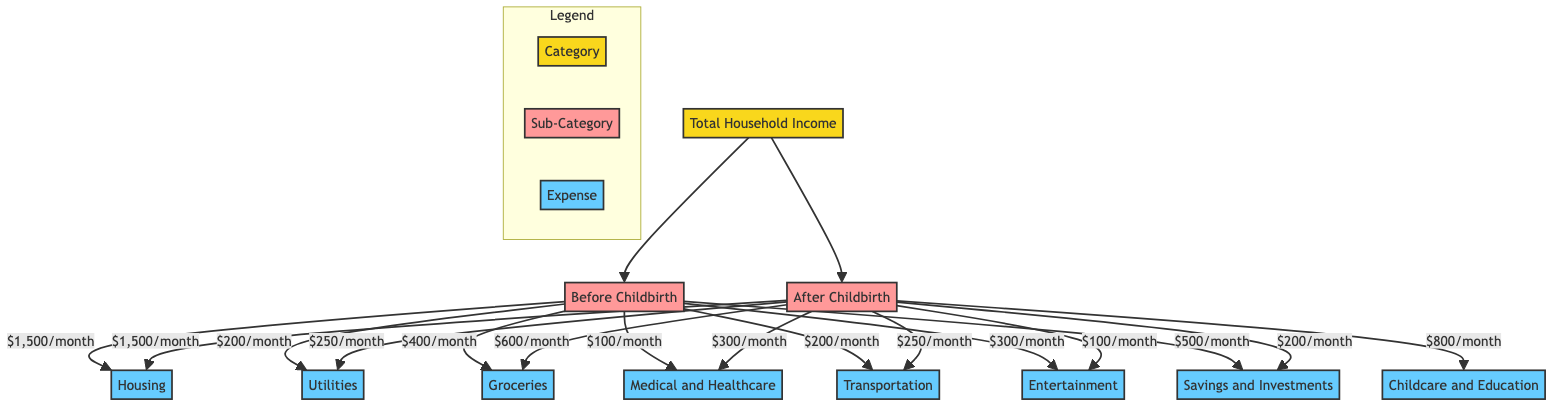What is the monthly expense for housing before childbirth? The diagram indicates that the monthly expense for housing before childbirth is $1,500. This is directly located under the "Before Childbirth" category connected to the "Housing" node.
Answer: $1,500 What is the increase in the monthly grocery expense after childbirth? The diagram shows that the monthly grocery expense before childbirth is $400, while after childbirth, it rises to $600. The increase can be calculated as $600 - $400, which equals $200.
Answer: $200 How much is allocated monthly for childcare and education after childbirth? According to the diagram, the monthly allocation for childcare and education after childbirth is $800. This is explicitly stated under the "After Childbirth" category connected to the "Childcare and Education" node.
Answer: $800 What is the total monthly spending on medical and healthcare before childbirth? The monthly expense for medical and healthcare before childbirth is $100, as shown in the diagram, under the "Before Childbirth" category connected to the "Medical and Healthcare" node.
Answer: $100 What is the ratio of savings after childbirth to savings before childbirth? The diagram indicates that savings before childbirth is $500 and after childbirth is $200. The ratio can be calculated as $200 : $500, which simplifies to 2:5 when both numbers are divided by 100.
Answer: 2:5 How has the monthly entertainment expense changed after childbirth? The diagram shows that the monthly entertainment expense before childbirth is $300 and after childbirth it drops to $100. The change is thus $300 - $100, which indicates a reduction of $200 in spending.
Answer: decreased by $200 How many expense categories are compared in the diagram? The diagram illustrates a total of seven expense categories, including Housing, Utilities, Groceries, Childcare and Education, Medical and Healthcare, Transportation, and Entertainment. Each of these categories can be counted under both "Before" and "After" childbirth.
Answer: 7 Which expense category has the highest allocation after childbirth? The diagram displays that the highest allocation after childbirth is $800 for Childcare and Education. This value is the largest among all expense categories listed in the "After Childbirth" section.
Answer: Childcare and Education What is the total change in monthly expenses from before to after childbirth for groceries and childcare combined? Before childbirth, groceries are $400 and childcare is $0; after childbirth, groceries are $600 and childcare is $800. To find the total change: (Groceries after - Groceries before) + (Childcare after - Childcare before) = ($600 - $400) + ($800 - $0) which equals $200 + $800 = $1,000.
Answer: $1,000 